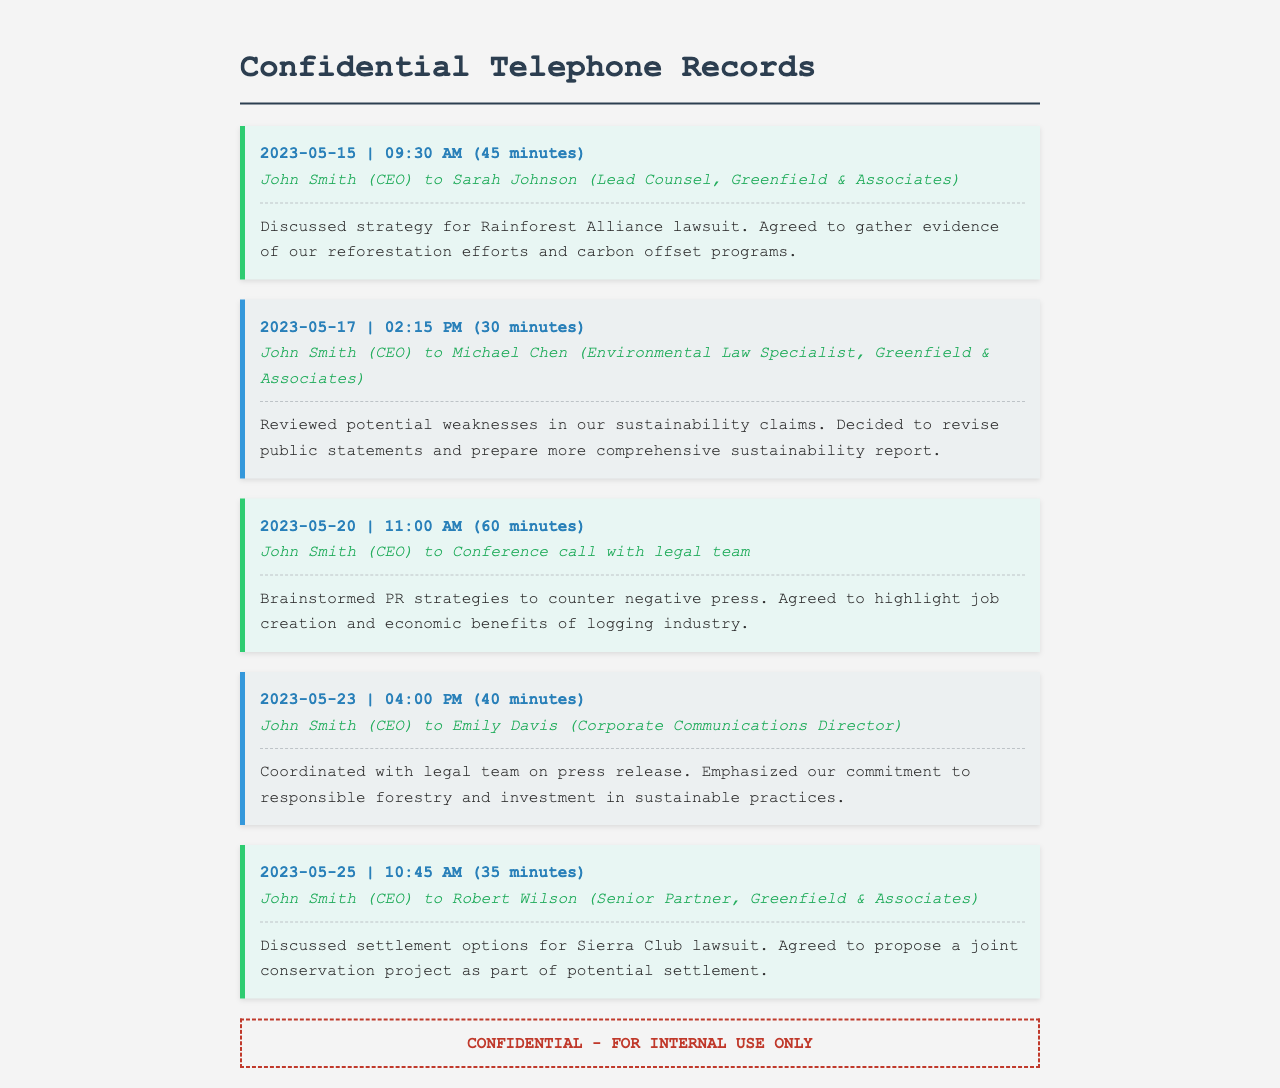What is the date of the call regarding the Rainforest Alliance lawsuit? The date of the call discussing the Rainforest Alliance lawsuit is 2023-05-15.
Answer: 2023-05-15 Who was involved in the call on May 17? The call on May 17 involved John Smith and Michael Chen.
Answer: John Smith and Michael Chen What was a key topic discussed in the May 20 call? A key topic in the May 20 call was brainstorming PR strategies to counter negative press.
Answer: PR strategies How long did the call on May 25 last? The call on May 25 lasted for 35 minutes.
Answer: 35 minutes What settlement option was discussed in relation to the Sierra Club lawsuit? In relation to the Sierra Club lawsuit, a joint conservation project was discussed as a settlement option.
Answer: joint conservation project How many calls were made with the legal team during May? There were four calls made with the legal team during May.
Answer: four What was the primary focus of the call on May 23? The primary focus of the call on May 23 was coordinating a press release.
Answer: press release What type of document are these records classified as? These records are classified as confidential telephone records.
Answer: confidential telephone records 